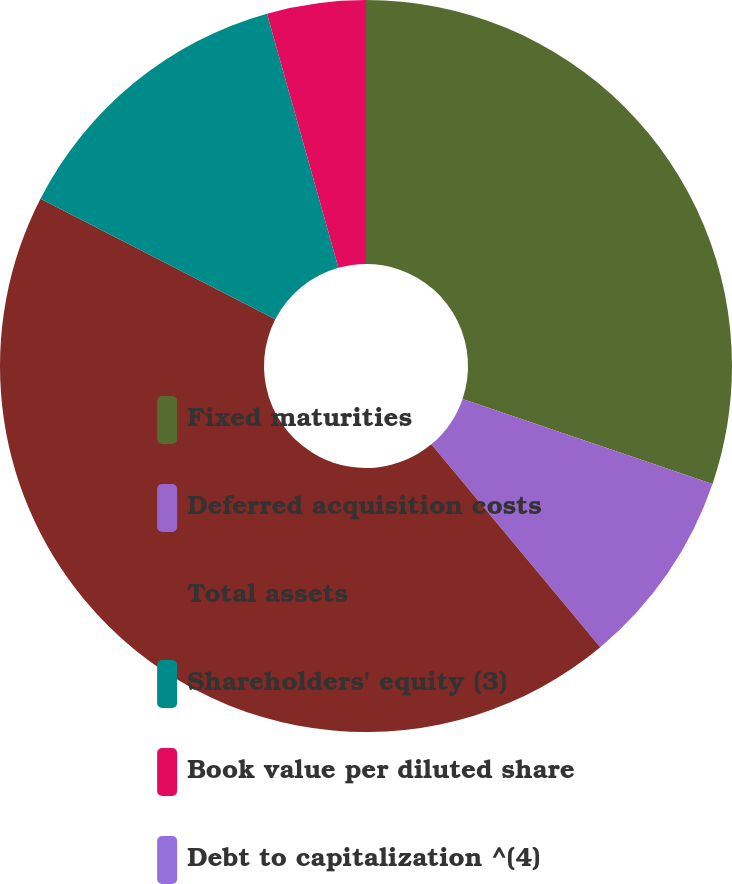Convert chart. <chart><loc_0><loc_0><loc_500><loc_500><pie_chart><fcel>Fixed maturities<fcel>Deferred acquisition costs<fcel>Total assets<fcel>Shareholders' equity (3)<fcel>Book value per diluted share<fcel>Debt to capitalization ^(4)<nl><fcel>30.22%<fcel>8.72%<fcel>43.61%<fcel>13.08%<fcel>4.36%<fcel>0.0%<nl></chart> 